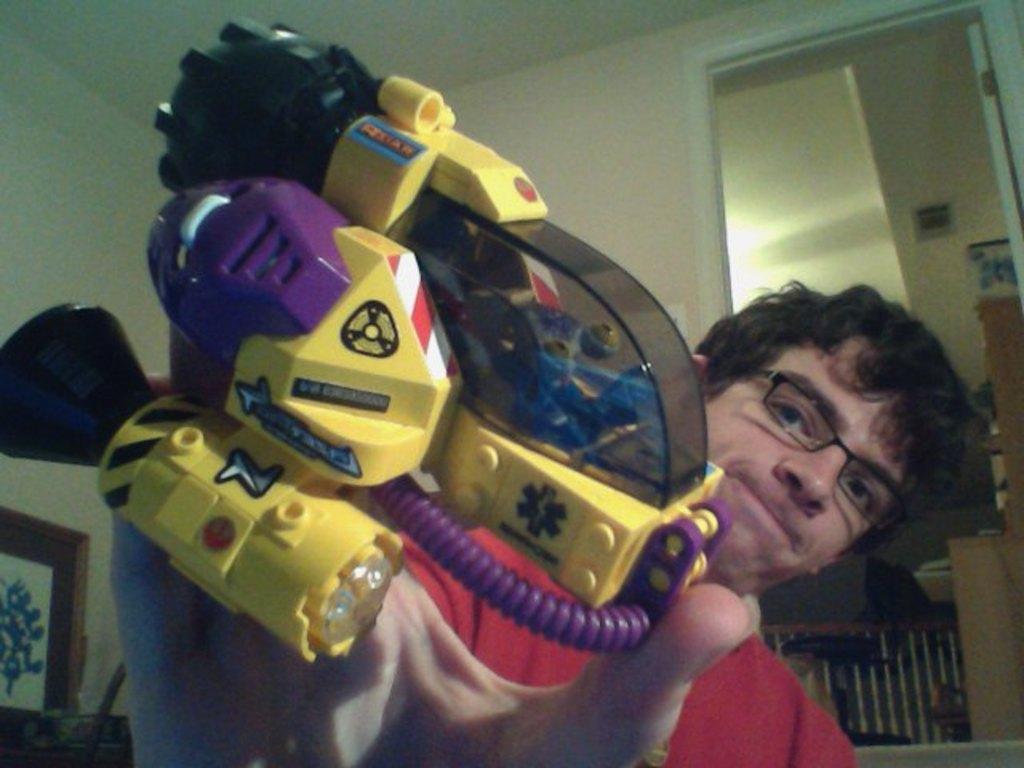Could you give a brief overview of what you see in this image? In this image I can see a person wearing red colored dress and spectacles is holding a toy which is yellow, black, red , white, blue and purple in color. In the background I can see the wall, the ceiling, the door and a photo frame. 